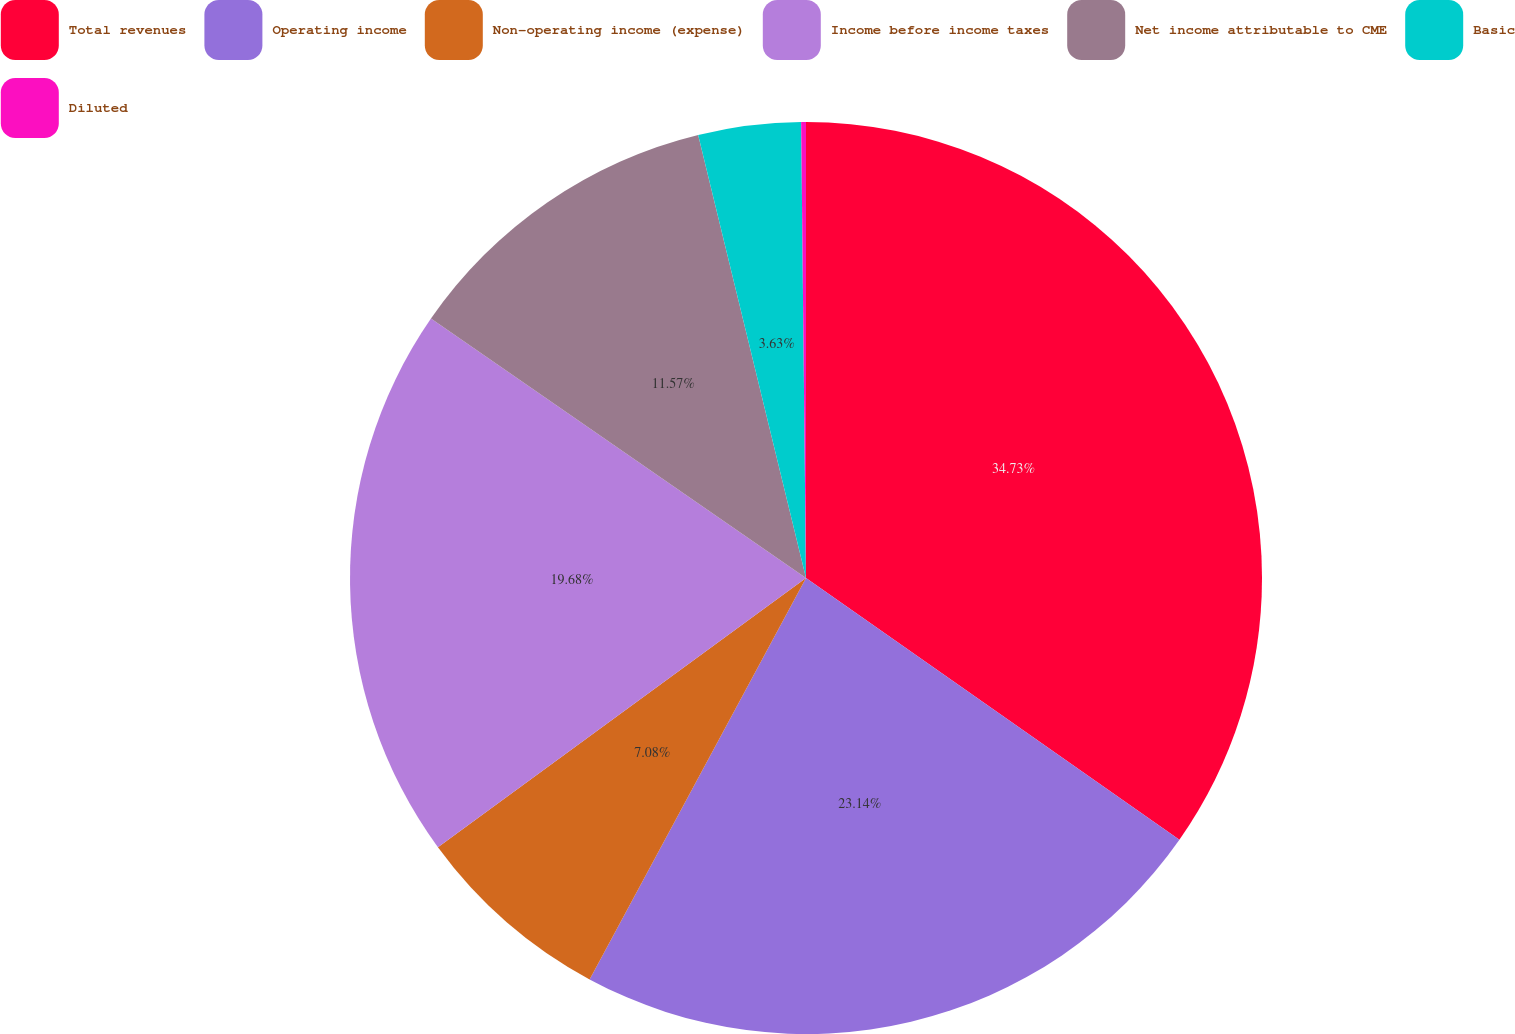Convert chart to OTSL. <chart><loc_0><loc_0><loc_500><loc_500><pie_chart><fcel>Total revenues<fcel>Operating income<fcel>Non-operating income (expense)<fcel>Income before income taxes<fcel>Net income attributable to CME<fcel>Basic<fcel>Diluted<nl><fcel>34.73%<fcel>23.14%<fcel>7.08%<fcel>19.68%<fcel>11.57%<fcel>3.63%<fcel>0.17%<nl></chart> 